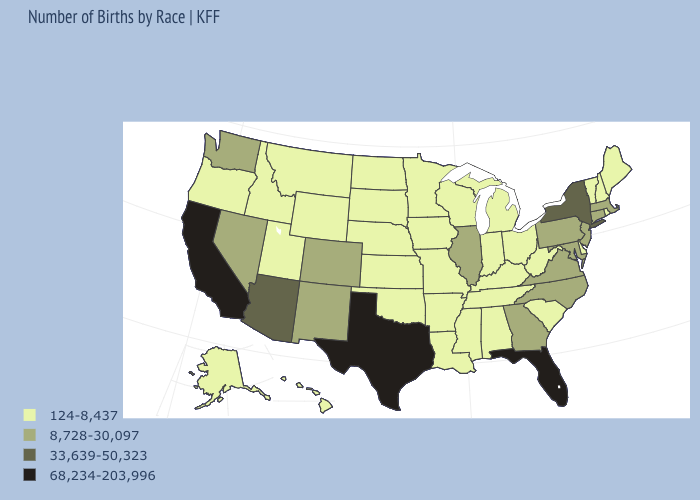Which states have the lowest value in the USA?
Short answer required. Alabama, Alaska, Arkansas, Delaware, Hawaii, Idaho, Indiana, Iowa, Kansas, Kentucky, Louisiana, Maine, Michigan, Minnesota, Mississippi, Missouri, Montana, Nebraska, New Hampshire, North Dakota, Ohio, Oklahoma, Oregon, Rhode Island, South Carolina, South Dakota, Tennessee, Utah, Vermont, West Virginia, Wisconsin, Wyoming. What is the value of Pennsylvania?
Answer briefly. 8,728-30,097. Name the states that have a value in the range 124-8,437?
Short answer required. Alabama, Alaska, Arkansas, Delaware, Hawaii, Idaho, Indiana, Iowa, Kansas, Kentucky, Louisiana, Maine, Michigan, Minnesota, Mississippi, Missouri, Montana, Nebraska, New Hampshire, North Dakota, Ohio, Oklahoma, Oregon, Rhode Island, South Carolina, South Dakota, Tennessee, Utah, Vermont, West Virginia, Wisconsin, Wyoming. What is the value of Ohio?
Quick response, please. 124-8,437. Does Georgia have a higher value than South Carolina?
Be succinct. Yes. Does New Mexico have the same value as Wisconsin?
Write a very short answer. No. Does Washington have the same value as Illinois?
Quick response, please. Yes. Is the legend a continuous bar?
Answer briefly. No. What is the highest value in the Northeast ?
Keep it brief. 33,639-50,323. Does Wisconsin have a lower value than Mississippi?
Write a very short answer. No. How many symbols are there in the legend?
Concise answer only. 4. Does Oklahoma have the same value as Oregon?
Give a very brief answer. Yes. What is the value of North Dakota?
Concise answer only. 124-8,437. Does Alabama have the lowest value in the South?
Keep it brief. Yes. Name the states that have a value in the range 8,728-30,097?
Answer briefly. Colorado, Connecticut, Georgia, Illinois, Maryland, Massachusetts, Nevada, New Jersey, New Mexico, North Carolina, Pennsylvania, Virginia, Washington. 